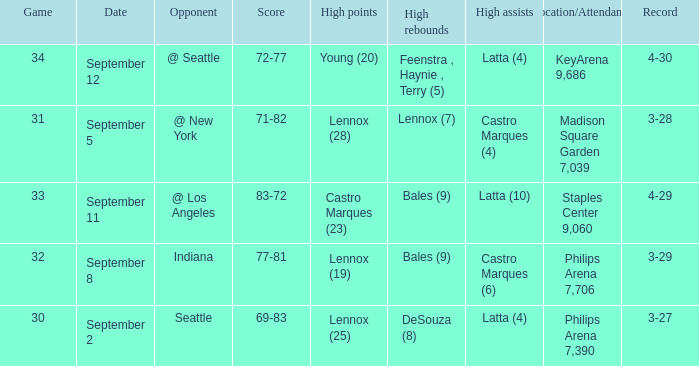What were the high rebounds on september 11? Bales (9). 